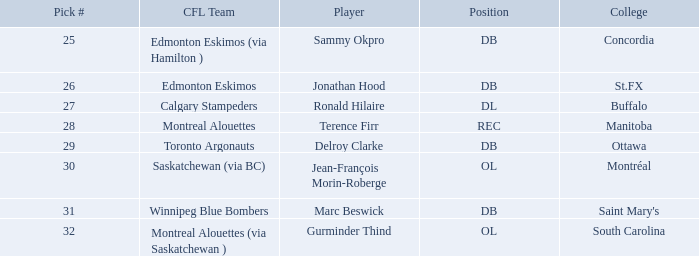Which Pick # has a College of concordia? 25.0. 